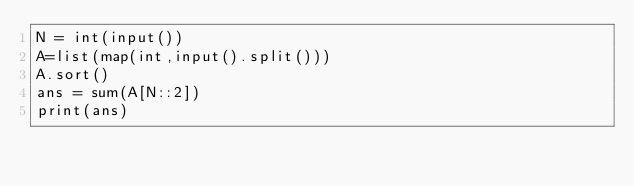<code> <loc_0><loc_0><loc_500><loc_500><_Python_>N = int(input())
A=list(map(int,input().split()))
A.sort()
ans = sum(A[N::2])
print(ans)</code> 